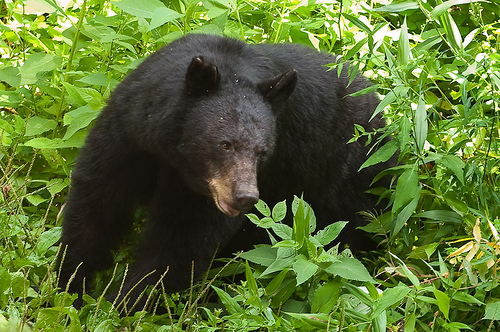<image>
Is the bear next to the plants? Yes. The bear is positioned adjacent to the plants, located nearby in the same general area. 